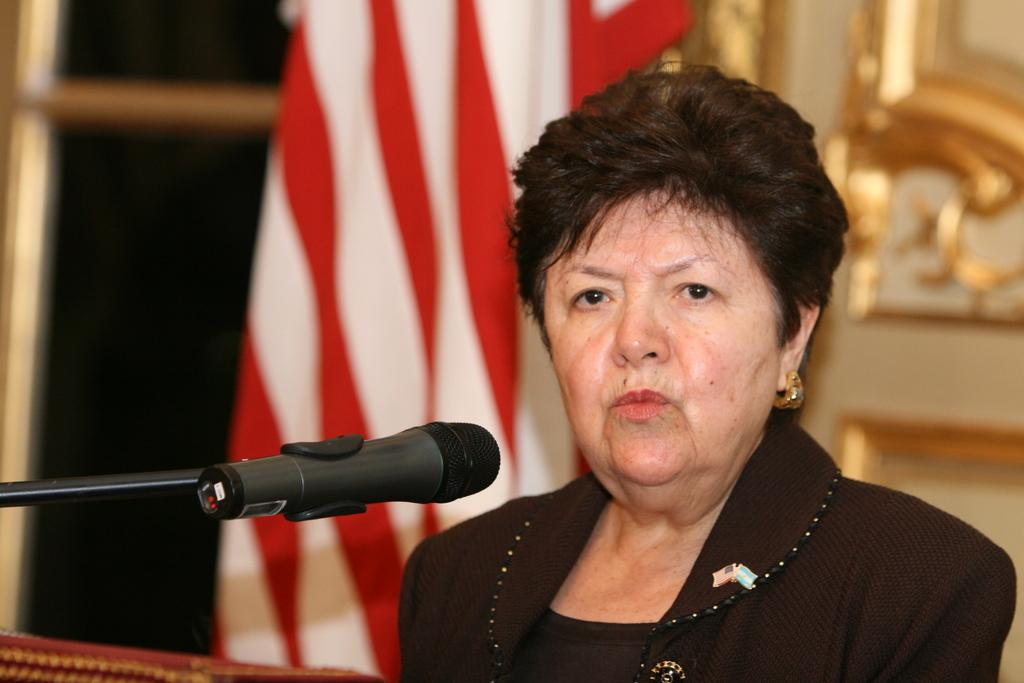What is the main subject of the image? The main subject of the image is a woman. What is the woman doing in the image? The woman is in front of a microphone. What additional element can be seen in the image? There is a flag visible in the image. Can you tell me how many cats are running around the tin in the image? There are no cats or tin present in the image. 